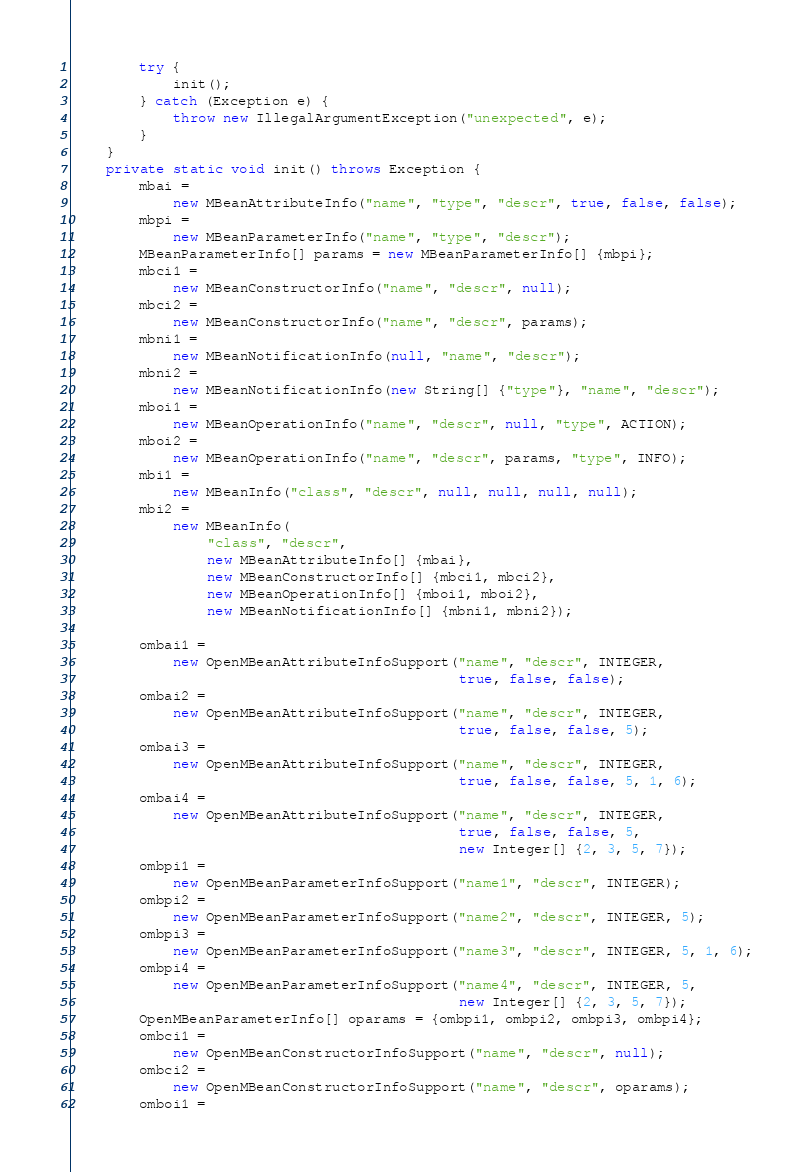Convert code to text. <code><loc_0><loc_0><loc_500><loc_500><_Java_>        try {
            init();
        } catch (Exception e) {
            throw new IllegalArgumentException("unexpected", e);
        }
    }
    private static void init() throws Exception {
        mbai =
            new MBeanAttributeInfo("name", "type", "descr", true, false, false);
        mbpi =
            new MBeanParameterInfo("name", "type", "descr");
        MBeanParameterInfo[] params = new MBeanParameterInfo[] {mbpi};
        mbci1 =
            new MBeanConstructorInfo("name", "descr", null);
        mbci2 =
            new MBeanConstructorInfo("name", "descr", params);
        mbni1 =
            new MBeanNotificationInfo(null, "name", "descr");
        mbni2 =
            new MBeanNotificationInfo(new String[] {"type"}, "name", "descr");
        mboi1 =
            new MBeanOperationInfo("name", "descr", null, "type", ACTION);
        mboi2 =
            new MBeanOperationInfo("name", "descr", params, "type", INFO);
        mbi1 =
            new MBeanInfo("class", "descr", null, null, null, null);
        mbi2 =
            new MBeanInfo(
                "class", "descr",
                new MBeanAttributeInfo[] {mbai},
                new MBeanConstructorInfo[] {mbci1, mbci2},
                new MBeanOperationInfo[] {mboi1, mboi2},
                new MBeanNotificationInfo[] {mbni1, mbni2});

        ombai1 =
            new OpenMBeanAttributeInfoSupport("name", "descr", INTEGER,
                                              true, false, false);
        ombai2 =
            new OpenMBeanAttributeInfoSupport("name", "descr", INTEGER,
                                              true, false, false, 5);
        ombai3 =
            new OpenMBeanAttributeInfoSupport("name", "descr", INTEGER,
                                              true, false, false, 5, 1, 6);
        ombai4 =
            new OpenMBeanAttributeInfoSupport("name", "descr", INTEGER,
                                              true, false, false, 5,
                                              new Integer[] {2, 3, 5, 7});
        ombpi1 =
            new OpenMBeanParameterInfoSupport("name1", "descr", INTEGER);
        ombpi2 =
            new OpenMBeanParameterInfoSupport("name2", "descr", INTEGER, 5);
        ombpi3 =
            new OpenMBeanParameterInfoSupport("name3", "descr", INTEGER, 5, 1, 6);
        ombpi4 =
            new OpenMBeanParameterInfoSupport("name4", "descr", INTEGER, 5,
                                              new Integer[] {2, 3, 5, 7});
        OpenMBeanParameterInfo[] oparams = {ombpi1, ombpi2, ombpi3, ombpi4};
        ombci1 =
            new OpenMBeanConstructorInfoSupport("name", "descr", null);
        ombci2 =
            new OpenMBeanConstructorInfoSupport("name", "descr", oparams);
        omboi1 =</code> 